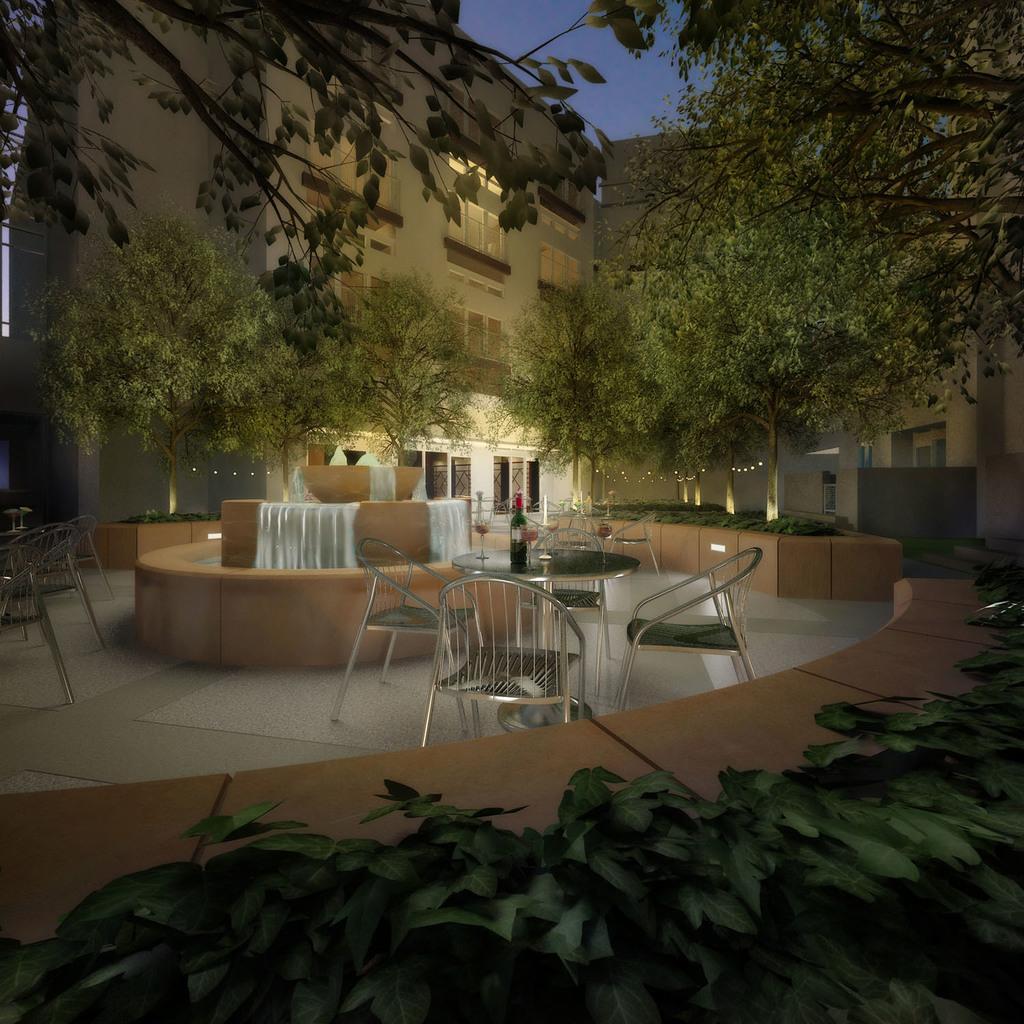Could you give a brief overview of what you see in this image? In the foreground of the picture there are plants. In the center of the picture there are chairs, tables, fountain, bottle, wall and plants. In the background there are trees and building. 